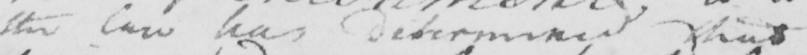Please provide the text content of this handwritten line. the law has determined that 